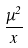<formula> <loc_0><loc_0><loc_500><loc_500>\frac { \mu ^ { 2 } } { x }</formula> 